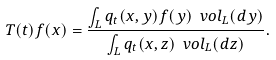Convert formula to latex. <formula><loc_0><loc_0><loc_500><loc_500>T ( t ) f ( x ) = \frac { \int _ { L } q _ { t } ( x , y ) f ( y ) \ v o l _ { L } ( d y ) } { \int _ { L } q _ { t } ( x , z ) \ v o l _ { L } ( d z ) } .</formula> 